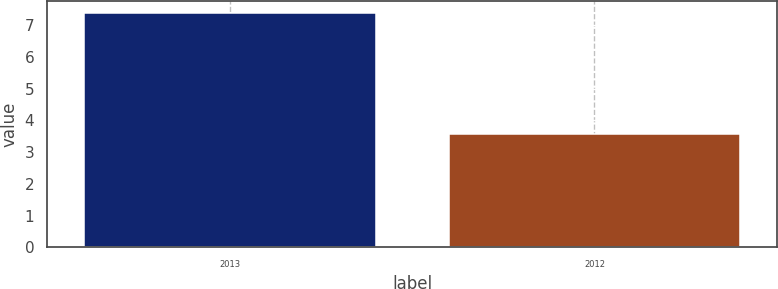Convert chart. <chart><loc_0><loc_0><loc_500><loc_500><bar_chart><fcel>2013<fcel>2012<nl><fcel>7.4<fcel>3.57<nl></chart> 